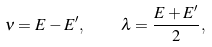<formula> <loc_0><loc_0><loc_500><loc_500>\nu = E - E ^ { \prime } , \quad \lambda = \frac { E + E ^ { \prime } } 2 ,</formula> 